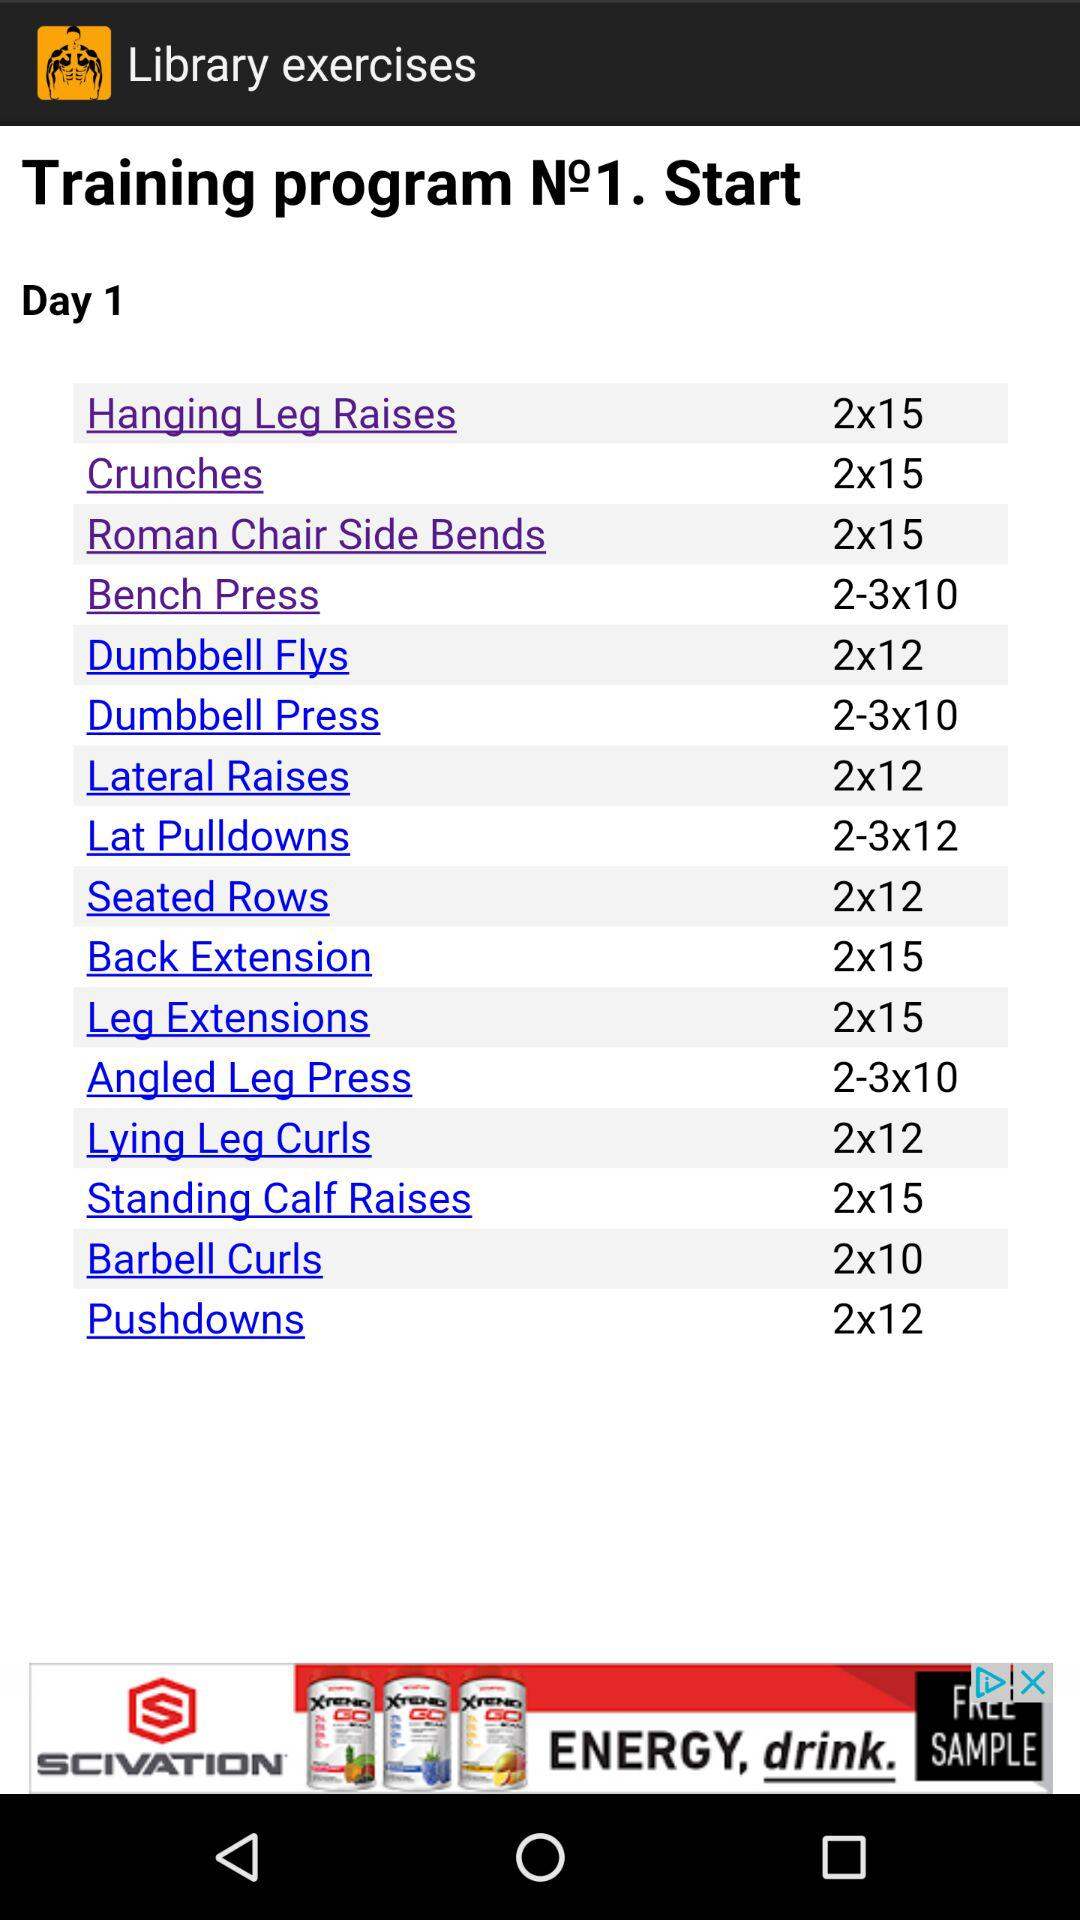Which training program number are we on? You are on the first training program. 